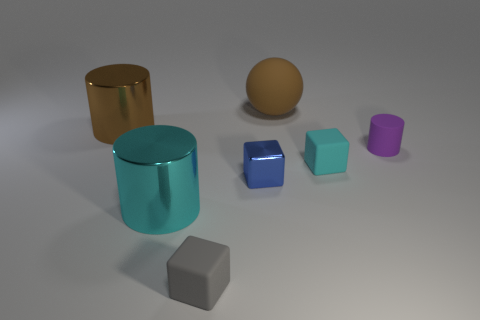There is a cyan metal thing; are there any cylinders to the right of it?
Ensure brevity in your answer.  Yes. Do the big thing to the right of the small gray matte object and the cyan thing left of the tiny gray block have the same shape?
Provide a succinct answer. No. There is another large thing that is the same shape as the large brown metallic object; what is it made of?
Give a very brief answer. Metal. What number of cylinders are big things or cyan rubber things?
Offer a very short reply. 2. How many tiny cyan things have the same material as the purple thing?
Ensure brevity in your answer.  1. Is the material of the brown object that is left of the gray matte cube the same as the cyan thing that is on the left side of the gray rubber thing?
Ensure brevity in your answer.  Yes. There is a brown thing in front of the large brown matte sphere that is on the right side of the big cyan shiny object; how many tiny objects are to the left of it?
Make the answer very short. 0. There is a cylinder that is right of the brown sphere; is it the same color as the cylinder that is in front of the cyan matte object?
Ensure brevity in your answer.  No. Is there anything else that is the same color as the matte cylinder?
Offer a terse response. No. The shiny cylinder that is in front of the brown object on the left side of the small gray thing is what color?
Ensure brevity in your answer.  Cyan. 